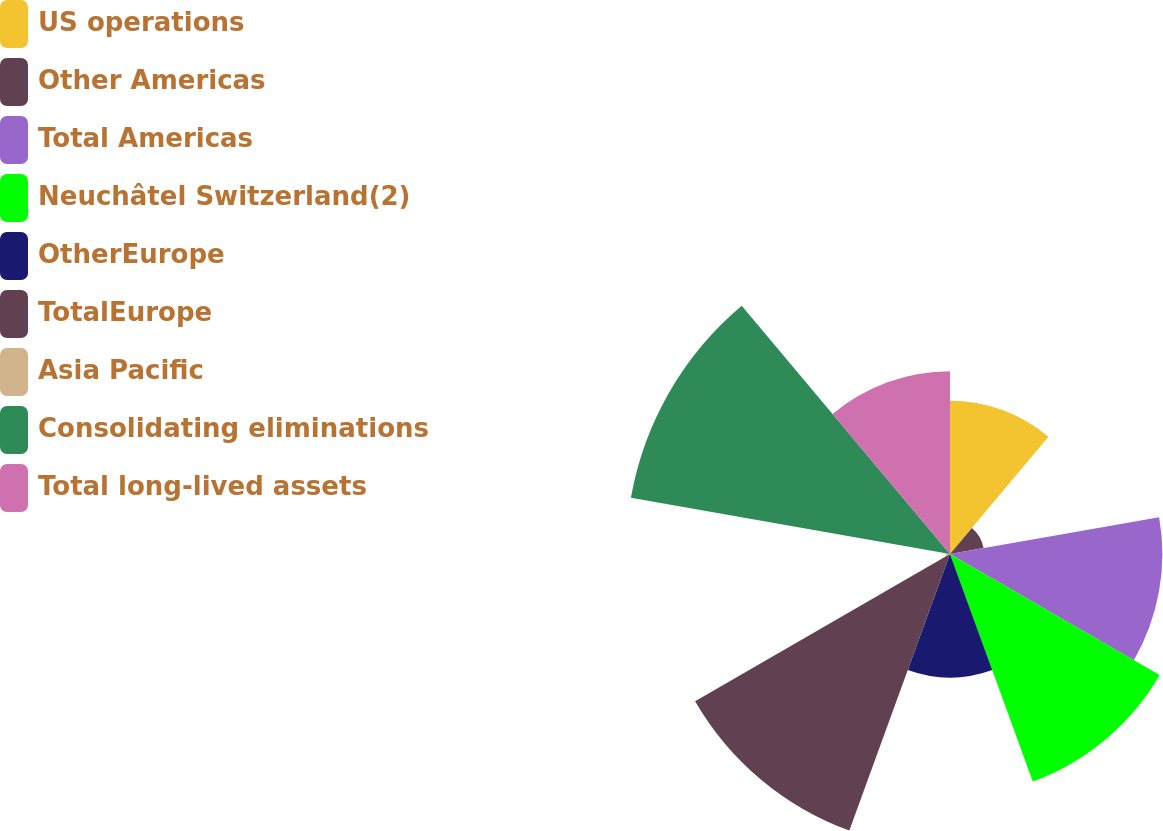Convert chart to OTSL. <chart><loc_0><loc_0><loc_500><loc_500><pie_chart><fcel>US operations<fcel>Other Americas<fcel>Total Americas<fcel>Neuchâtel Switzerland(2)<fcel>OtherEurope<fcel>TotalEurope<fcel>Asia Pacific<fcel>Consolidating eliminations<fcel>Total long-lived assets<nl><fcel>9.75%<fcel>2.17%<fcel>13.52%<fcel>15.41%<fcel>7.86%<fcel>18.74%<fcel>0.28%<fcel>20.63%<fcel>11.64%<nl></chart> 